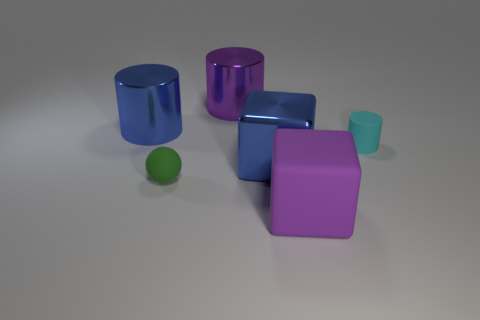Subtract 1 cylinders. How many cylinders are left? 2 Add 2 small matte spheres. How many objects exist? 8 Subtract all blocks. How many objects are left? 4 Add 6 large purple cylinders. How many large purple cylinders are left? 7 Add 2 cyan spheres. How many cyan spheres exist? 2 Subtract 0 gray cylinders. How many objects are left? 6 Subtract all matte spheres. Subtract all purple rubber objects. How many objects are left? 4 